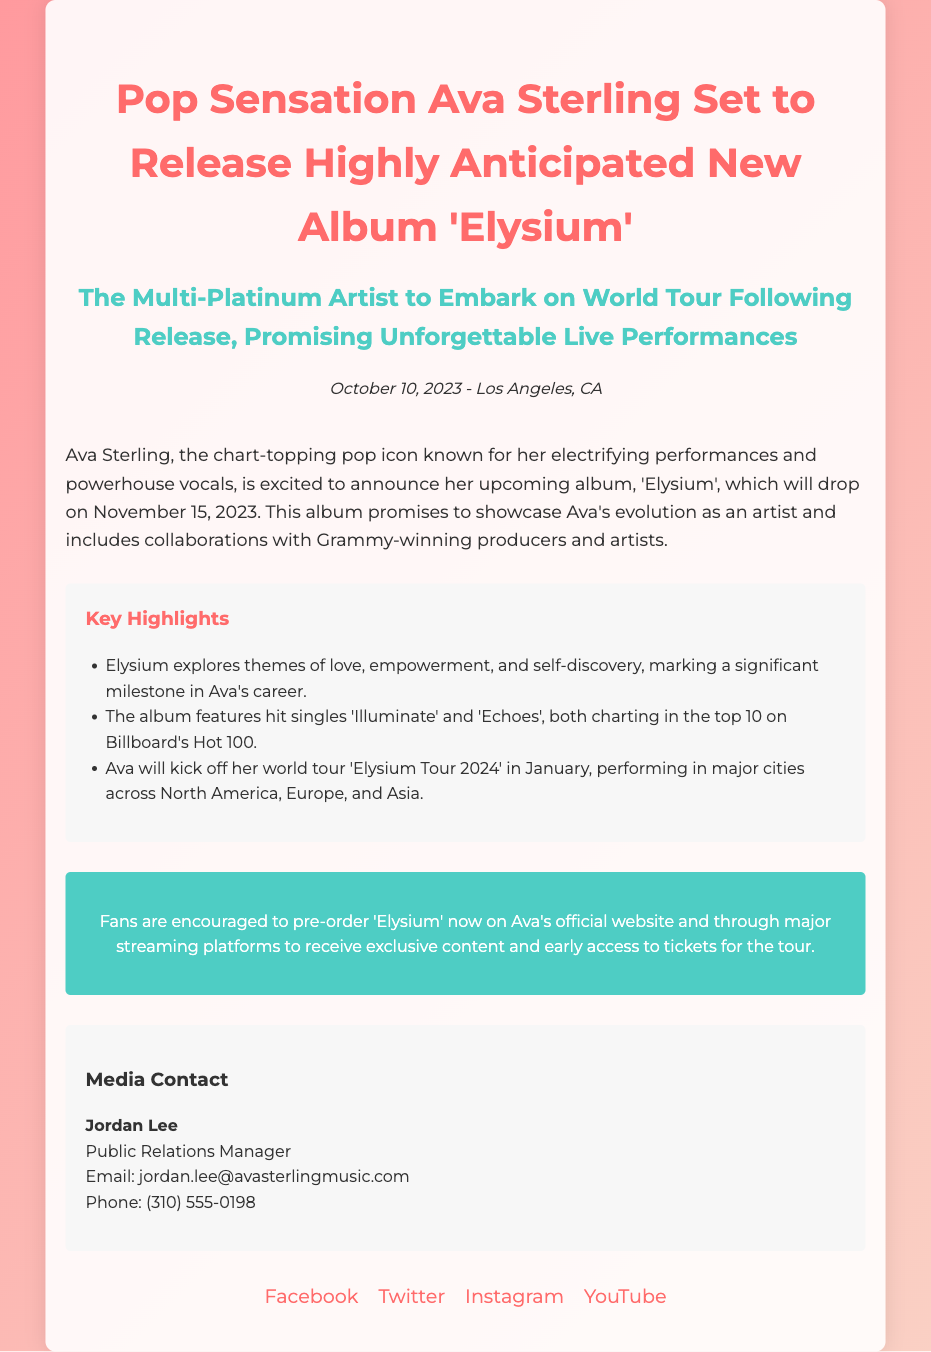What is the name of Ava Sterling's upcoming album? The name of the album is stated in the announcement as 'Elysium'.
Answer: 'Elysium' When is the album release date? The release date is specified in the document as November 15, 2023.
Answer: November 15, 2023 Who is the Public Relations Manager? The contact section identifies Jordan Lee as the Public Relations Manager.
Answer: Jordan Lee What are the titles of the two hit singles mentioned? The document lists the hit singles as 'Illuminate' and 'Echoes'.
Answer: 'Illuminate' and 'Echoes' In which month will the world tour begin? The document indicates that the world tour will start in January.
Answer: January What themes does the album 'Elysium' explore? The key messages section lists love, empowerment, and self-discovery as themes of the album.
Answer: Love, empowerment, and self-discovery How can fans get early access to concert tickets? Fans can receive early access to tickets by pre-ordering the album as detailed in the document.
Answer: Pre-ordering the album How many cities will the world tour cover? The document suggests that the tour will perform in major cities across North America, Europe, and Asia, but does not specify the exact number.
Answer: Major cities across North America, Europe, and Asia What is the color of the album launch announcement's primary heading? The primary heading is colored in #ff6b6b, which is a pink shade specified in the style.
Answer: #ff6b6b 